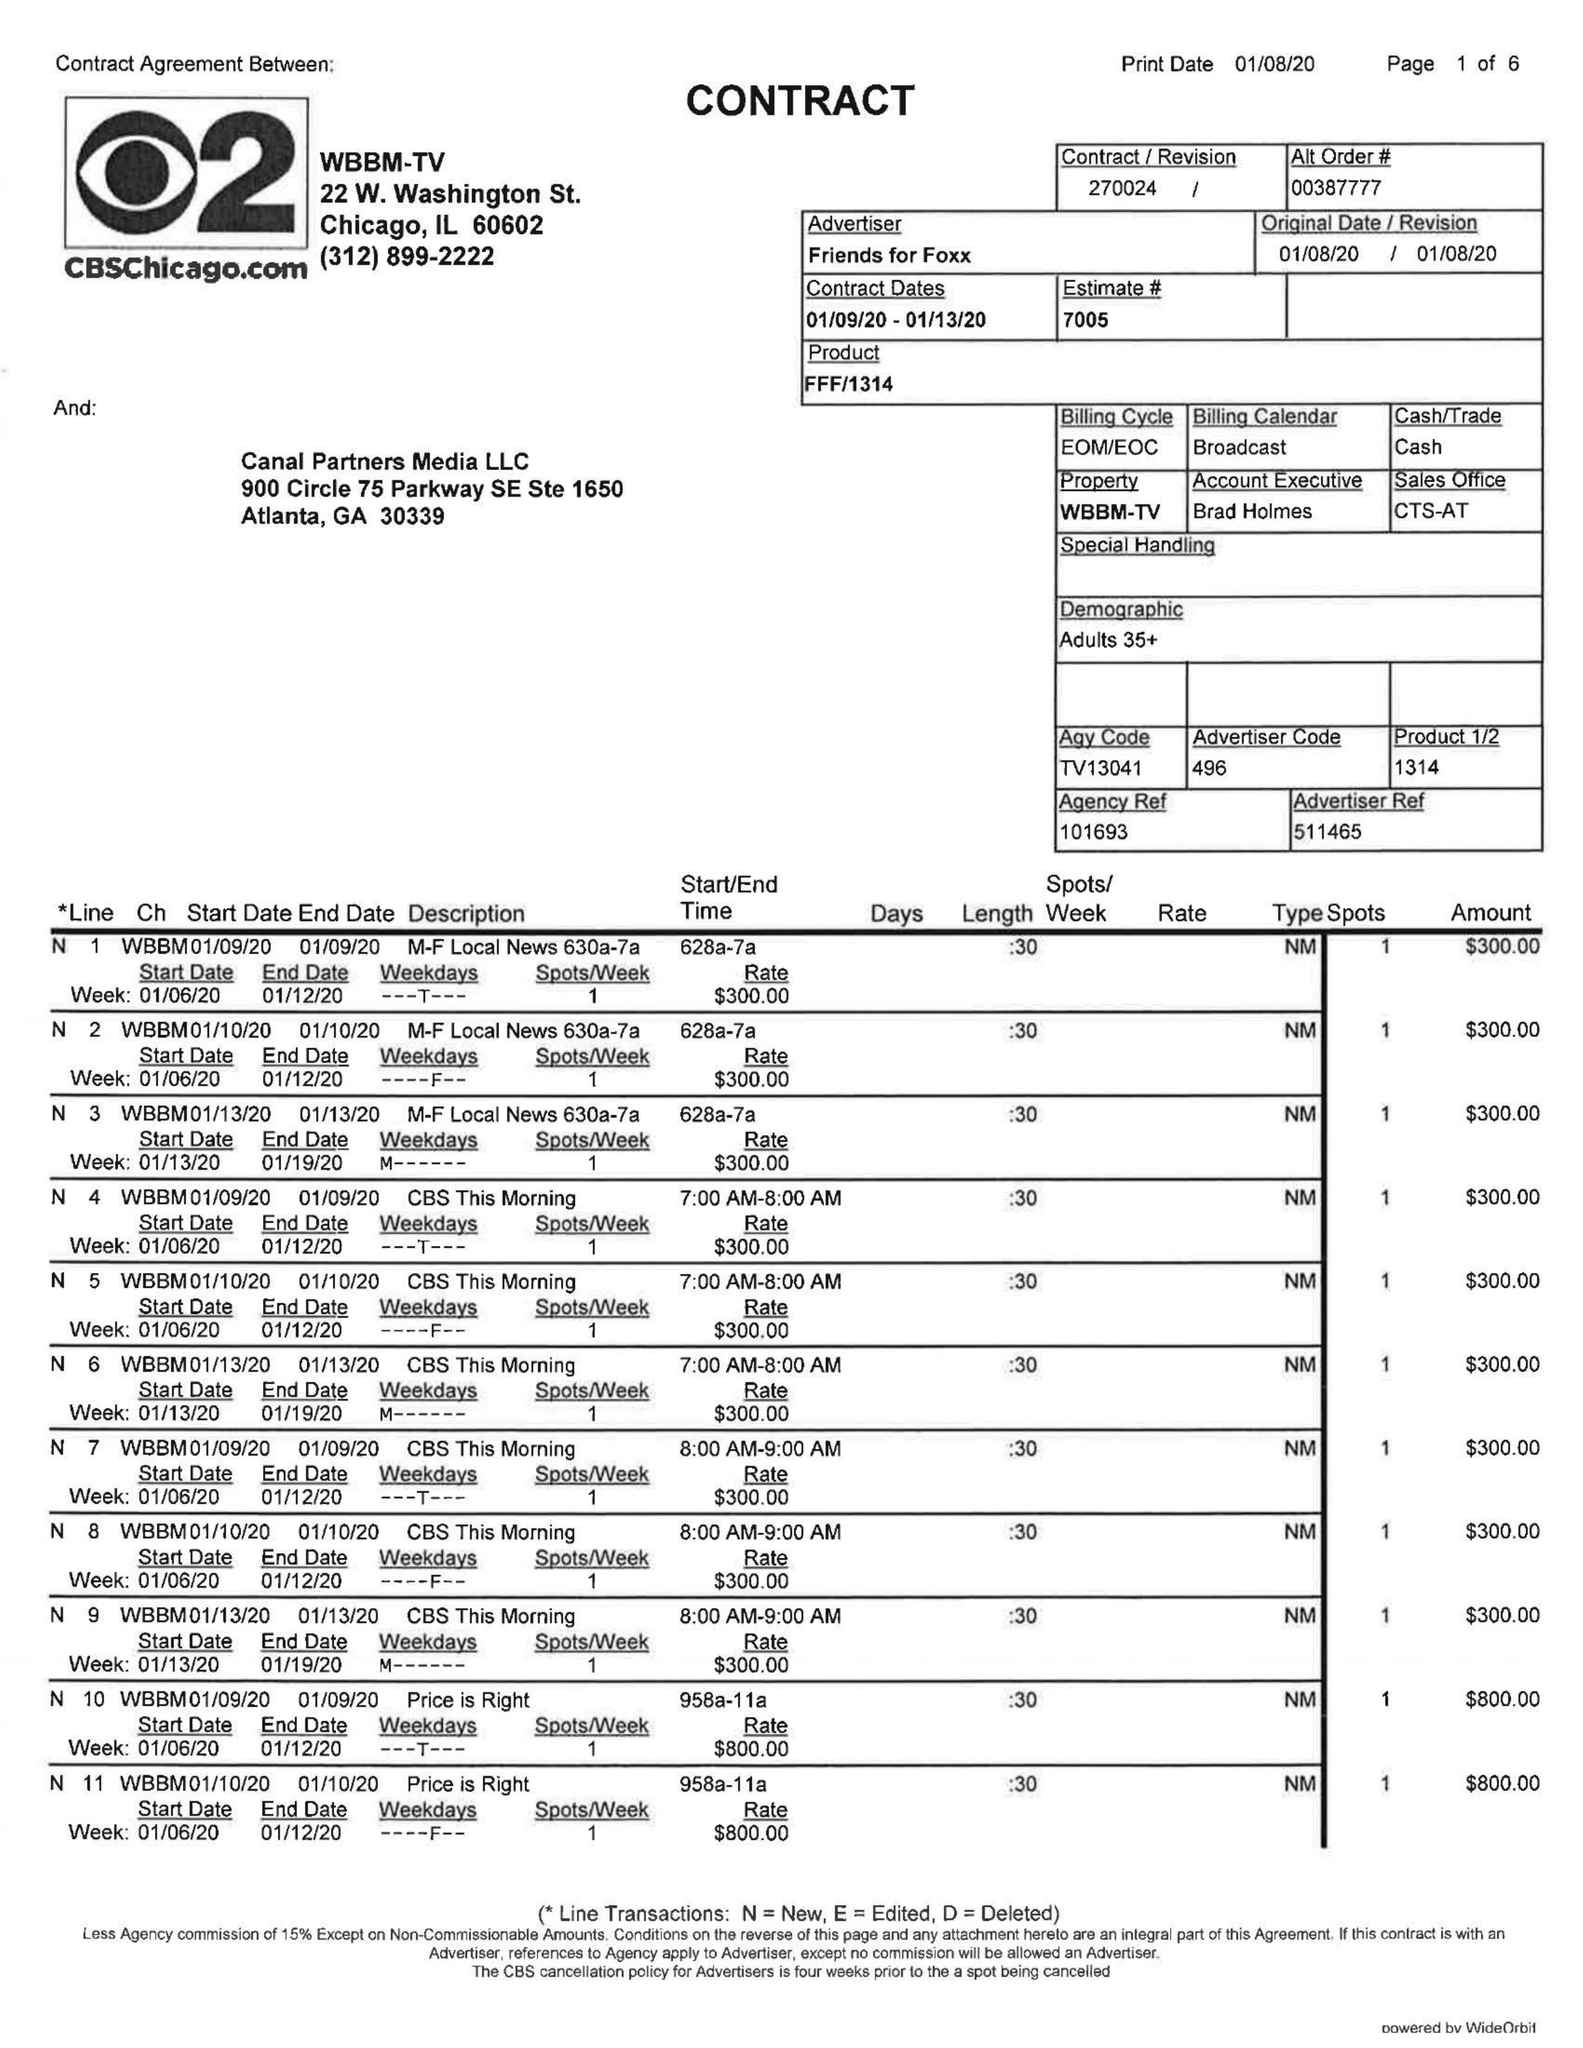What is the value for the advertiser?
Answer the question using a single word or phrase. FRIENDS FOR FOXX 